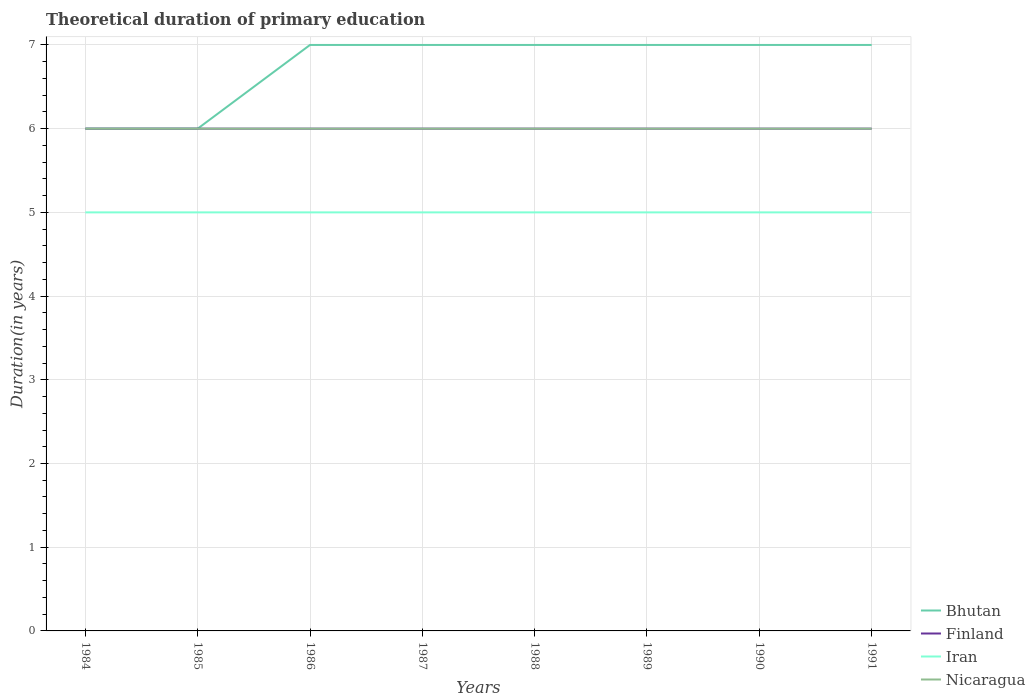Does the line corresponding to Nicaragua intersect with the line corresponding to Finland?
Offer a very short reply. Yes. Is the number of lines equal to the number of legend labels?
Your answer should be compact. Yes. Across all years, what is the maximum total theoretical duration of primary education in Iran?
Your answer should be very brief. 5. How many lines are there?
Your response must be concise. 4. How many years are there in the graph?
Provide a succinct answer. 8. What is the difference between two consecutive major ticks on the Y-axis?
Your response must be concise. 1. Are the values on the major ticks of Y-axis written in scientific E-notation?
Give a very brief answer. No. Does the graph contain any zero values?
Keep it short and to the point. No. Where does the legend appear in the graph?
Your answer should be compact. Bottom right. How many legend labels are there?
Your answer should be very brief. 4. How are the legend labels stacked?
Offer a very short reply. Vertical. What is the title of the graph?
Offer a terse response. Theoretical duration of primary education. Does "Marshall Islands" appear as one of the legend labels in the graph?
Give a very brief answer. No. What is the label or title of the X-axis?
Your response must be concise. Years. What is the label or title of the Y-axis?
Ensure brevity in your answer.  Duration(in years). What is the Duration(in years) in Bhutan in 1984?
Your response must be concise. 6. What is the Duration(in years) of Iran in 1984?
Make the answer very short. 5. What is the Duration(in years) of Nicaragua in 1984?
Offer a terse response. 6. What is the Duration(in years) in Bhutan in 1985?
Provide a short and direct response. 6. What is the Duration(in years) in Iran in 1985?
Provide a succinct answer. 5. What is the Duration(in years) in Nicaragua in 1986?
Offer a terse response. 6. What is the Duration(in years) in Iran in 1987?
Keep it short and to the point. 5. What is the Duration(in years) of Iran in 1988?
Provide a short and direct response. 5. What is the Duration(in years) in Bhutan in 1989?
Ensure brevity in your answer.  7. What is the Duration(in years) in Finland in 1989?
Make the answer very short. 6. What is the Duration(in years) in Nicaragua in 1989?
Make the answer very short. 6. What is the Duration(in years) of Iran in 1990?
Provide a succinct answer. 5. What is the Duration(in years) in Nicaragua in 1990?
Offer a very short reply. 6. What is the Duration(in years) in Bhutan in 1991?
Provide a succinct answer. 7. What is the Duration(in years) of Finland in 1991?
Offer a very short reply. 6. What is the Duration(in years) of Iran in 1991?
Offer a very short reply. 5. What is the Duration(in years) of Nicaragua in 1991?
Make the answer very short. 6. Across all years, what is the maximum Duration(in years) in Nicaragua?
Offer a terse response. 6. Across all years, what is the minimum Duration(in years) of Finland?
Make the answer very short. 6. Across all years, what is the minimum Duration(in years) in Nicaragua?
Your answer should be very brief. 6. What is the total Duration(in years) in Bhutan in the graph?
Keep it short and to the point. 54. What is the difference between the Duration(in years) of Finland in 1984 and that in 1985?
Offer a terse response. 0. What is the difference between the Duration(in years) in Iran in 1984 and that in 1987?
Your answer should be very brief. 0. What is the difference between the Duration(in years) of Nicaragua in 1984 and that in 1988?
Your response must be concise. 0. What is the difference between the Duration(in years) of Bhutan in 1984 and that in 1989?
Provide a short and direct response. -1. What is the difference between the Duration(in years) of Finland in 1984 and that in 1989?
Keep it short and to the point. 0. What is the difference between the Duration(in years) of Iran in 1984 and that in 1989?
Offer a terse response. 0. What is the difference between the Duration(in years) in Bhutan in 1984 and that in 1990?
Your answer should be very brief. -1. What is the difference between the Duration(in years) of Iran in 1984 and that in 1990?
Your answer should be very brief. 0. What is the difference between the Duration(in years) of Nicaragua in 1984 and that in 1990?
Offer a very short reply. 0. What is the difference between the Duration(in years) in Bhutan in 1984 and that in 1991?
Give a very brief answer. -1. What is the difference between the Duration(in years) of Finland in 1984 and that in 1991?
Offer a terse response. 0. What is the difference between the Duration(in years) of Nicaragua in 1984 and that in 1991?
Offer a very short reply. 0. What is the difference between the Duration(in years) in Bhutan in 1985 and that in 1986?
Make the answer very short. -1. What is the difference between the Duration(in years) in Iran in 1985 and that in 1986?
Provide a succinct answer. 0. What is the difference between the Duration(in years) in Nicaragua in 1985 and that in 1986?
Give a very brief answer. 0. What is the difference between the Duration(in years) in Bhutan in 1985 and that in 1987?
Provide a short and direct response. -1. What is the difference between the Duration(in years) in Nicaragua in 1985 and that in 1987?
Your answer should be compact. 0. What is the difference between the Duration(in years) of Bhutan in 1985 and that in 1988?
Ensure brevity in your answer.  -1. What is the difference between the Duration(in years) of Finland in 1985 and that in 1988?
Offer a very short reply. 0. What is the difference between the Duration(in years) in Iran in 1985 and that in 1988?
Provide a succinct answer. 0. What is the difference between the Duration(in years) in Finland in 1985 and that in 1989?
Offer a terse response. 0. What is the difference between the Duration(in years) in Bhutan in 1985 and that in 1990?
Keep it short and to the point. -1. What is the difference between the Duration(in years) of Finland in 1985 and that in 1990?
Provide a succinct answer. 0. What is the difference between the Duration(in years) of Nicaragua in 1985 and that in 1991?
Provide a succinct answer. 0. What is the difference between the Duration(in years) of Bhutan in 1986 and that in 1987?
Your answer should be very brief. 0. What is the difference between the Duration(in years) of Iran in 1986 and that in 1987?
Your response must be concise. 0. What is the difference between the Duration(in years) of Nicaragua in 1986 and that in 1987?
Your response must be concise. 0. What is the difference between the Duration(in years) of Iran in 1986 and that in 1988?
Your response must be concise. 0. What is the difference between the Duration(in years) in Finland in 1986 and that in 1989?
Ensure brevity in your answer.  0. What is the difference between the Duration(in years) of Bhutan in 1986 and that in 1990?
Provide a short and direct response. 0. What is the difference between the Duration(in years) in Finland in 1986 and that in 1990?
Your answer should be very brief. 0. What is the difference between the Duration(in years) in Bhutan in 1986 and that in 1991?
Make the answer very short. 0. What is the difference between the Duration(in years) in Finland in 1987 and that in 1988?
Offer a very short reply. 0. What is the difference between the Duration(in years) of Iran in 1987 and that in 1988?
Offer a terse response. 0. What is the difference between the Duration(in years) in Iran in 1987 and that in 1989?
Give a very brief answer. 0. What is the difference between the Duration(in years) of Finland in 1987 and that in 1990?
Offer a terse response. 0. What is the difference between the Duration(in years) in Iran in 1987 and that in 1990?
Your answer should be very brief. 0. What is the difference between the Duration(in years) in Bhutan in 1987 and that in 1991?
Your answer should be very brief. 0. What is the difference between the Duration(in years) in Finland in 1988 and that in 1989?
Offer a terse response. 0. What is the difference between the Duration(in years) in Iran in 1988 and that in 1989?
Your answer should be very brief. 0. What is the difference between the Duration(in years) in Nicaragua in 1988 and that in 1989?
Your answer should be compact. 0. What is the difference between the Duration(in years) in Nicaragua in 1988 and that in 1990?
Your response must be concise. 0. What is the difference between the Duration(in years) of Iran in 1988 and that in 1991?
Your answer should be very brief. 0. What is the difference between the Duration(in years) in Finland in 1989 and that in 1990?
Offer a terse response. 0. What is the difference between the Duration(in years) of Iran in 1989 and that in 1990?
Your answer should be very brief. 0. What is the difference between the Duration(in years) in Nicaragua in 1989 and that in 1990?
Make the answer very short. 0. What is the difference between the Duration(in years) in Bhutan in 1989 and that in 1991?
Offer a very short reply. 0. What is the difference between the Duration(in years) of Finland in 1989 and that in 1991?
Keep it short and to the point. 0. What is the difference between the Duration(in years) of Iran in 1989 and that in 1991?
Offer a very short reply. 0. What is the difference between the Duration(in years) in Nicaragua in 1989 and that in 1991?
Provide a succinct answer. 0. What is the difference between the Duration(in years) of Finland in 1990 and that in 1991?
Provide a short and direct response. 0. What is the difference between the Duration(in years) of Iran in 1990 and that in 1991?
Give a very brief answer. 0. What is the difference between the Duration(in years) of Bhutan in 1984 and the Duration(in years) of Finland in 1985?
Your answer should be compact. 0. What is the difference between the Duration(in years) in Bhutan in 1984 and the Duration(in years) in Iran in 1985?
Make the answer very short. 1. What is the difference between the Duration(in years) of Bhutan in 1984 and the Duration(in years) of Nicaragua in 1985?
Offer a very short reply. 0. What is the difference between the Duration(in years) of Finland in 1984 and the Duration(in years) of Nicaragua in 1985?
Give a very brief answer. 0. What is the difference between the Duration(in years) of Bhutan in 1984 and the Duration(in years) of Iran in 1986?
Provide a short and direct response. 1. What is the difference between the Duration(in years) of Bhutan in 1984 and the Duration(in years) of Nicaragua in 1986?
Keep it short and to the point. 0. What is the difference between the Duration(in years) in Finland in 1984 and the Duration(in years) in Iran in 1986?
Provide a short and direct response. 1. What is the difference between the Duration(in years) in Bhutan in 1984 and the Duration(in years) in Iran in 1987?
Make the answer very short. 1. What is the difference between the Duration(in years) of Bhutan in 1984 and the Duration(in years) of Nicaragua in 1987?
Ensure brevity in your answer.  0. What is the difference between the Duration(in years) in Finland in 1984 and the Duration(in years) in Nicaragua in 1987?
Make the answer very short. 0. What is the difference between the Duration(in years) of Bhutan in 1984 and the Duration(in years) of Nicaragua in 1988?
Your answer should be very brief. 0. What is the difference between the Duration(in years) in Iran in 1984 and the Duration(in years) in Nicaragua in 1988?
Your answer should be compact. -1. What is the difference between the Duration(in years) in Bhutan in 1984 and the Duration(in years) in Nicaragua in 1989?
Offer a terse response. 0. What is the difference between the Duration(in years) of Finland in 1984 and the Duration(in years) of Nicaragua in 1989?
Provide a succinct answer. 0. What is the difference between the Duration(in years) in Bhutan in 1984 and the Duration(in years) in Iran in 1990?
Offer a very short reply. 1. What is the difference between the Duration(in years) in Bhutan in 1984 and the Duration(in years) in Nicaragua in 1990?
Ensure brevity in your answer.  0. What is the difference between the Duration(in years) of Iran in 1984 and the Duration(in years) of Nicaragua in 1990?
Keep it short and to the point. -1. What is the difference between the Duration(in years) in Finland in 1984 and the Duration(in years) in Iran in 1991?
Provide a succinct answer. 1. What is the difference between the Duration(in years) of Iran in 1984 and the Duration(in years) of Nicaragua in 1991?
Your response must be concise. -1. What is the difference between the Duration(in years) in Bhutan in 1985 and the Duration(in years) in Finland in 1986?
Provide a succinct answer. 0. What is the difference between the Duration(in years) of Bhutan in 1985 and the Duration(in years) of Iran in 1986?
Make the answer very short. 1. What is the difference between the Duration(in years) in Bhutan in 1985 and the Duration(in years) in Nicaragua in 1986?
Give a very brief answer. 0. What is the difference between the Duration(in years) of Bhutan in 1985 and the Duration(in years) of Finland in 1987?
Make the answer very short. 0. What is the difference between the Duration(in years) in Finland in 1985 and the Duration(in years) in Iran in 1987?
Offer a very short reply. 1. What is the difference between the Duration(in years) in Finland in 1985 and the Duration(in years) in Nicaragua in 1987?
Ensure brevity in your answer.  0. What is the difference between the Duration(in years) of Bhutan in 1985 and the Duration(in years) of Iran in 1988?
Make the answer very short. 1. What is the difference between the Duration(in years) in Bhutan in 1985 and the Duration(in years) in Nicaragua in 1988?
Keep it short and to the point. 0. What is the difference between the Duration(in years) of Finland in 1985 and the Duration(in years) of Iran in 1988?
Provide a succinct answer. 1. What is the difference between the Duration(in years) of Finland in 1985 and the Duration(in years) of Nicaragua in 1988?
Your answer should be very brief. 0. What is the difference between the Duration(in years) of Iran in 1985 and the Duration(in years) of Nicaragua in 1988?
Make the answer very short. -1. What is the difference between the Duration(in years) in Bhutan in 1985 and the Duration(in years) in Iran in 1989?
Your answer should be compact. 1. What is the difference between the Duration(in years) of Bhutan in 1985 and the Duration(in years) of Nicaragua in 1989?
Provide a short and direct response. 0. What is the difference between the Duration(in years) in Iran in 1985 and the Duration(in years) in Nicaragua in 1989?
Ensure brevity in your answer.  -1. What is the difference between the Duration(in years) in Bhutan in 1985 and the Duration(in years) in Finland in 1990?
Your response must be concise. 0. What is the difference between the Duration(in years) in Bhutan in 1985 and the Duration(in years) in Iran in 1990?
Your answer should be compact. 1. What is the difference between the Duration(in years) of Bhutan in 1985 and the Duration(in years) of Nicaragua in 1990?
Offer a terse response. 0. What is the difference between the Duration(in years) in Finland in 1985 and the Duration(in years) in Iran in 1990?
Your response must be concise. 1. What is the difference between the Duration(in years) of Iran in 1985 and the Duration(in years) of Nicaragua in 1990?
Provide a succinct answer. -1. What is the difference between the Duration(in years) of Bhutan in 1985 and the Duration(in years) of Iran in 1991?
Ensure brevity in your answer.  1. What is the difference between the Duration(in years) in Bhutan in 1985 and the Duration(in years) in Nicaragua in 1991?
Ensure brevity in your answer.  0. What is the difference between the Duration(in years) of Iran in 1985 and the Duration(in years) of Nicaragua in 1991?
Provide a short and direct response. -1. What is the difference between the Duration(in years) of Bhutan in 1986 and the Duration(in years) of Finland in 1987?
Offer a very short reply. 1. What is the difference between the Duration(in years) of Finland in 1986 and the Duration(in years) of Iran in 1987?
Ensure brevity in your answer.  1. What is the difference between the Duration(in years) in Finland in 1986 and the Duration(in years) in Nicaragua in 1987?
Give a very brief answer. 0. What is the difference between the Duration(in years) in Bhutan in 1986 and the Duration(in years) in Finland in 1988?
Make the answer very short. 1. What is the difference between the Duration(in years) in Bhutan in 1986 and the Duration(in years) in Nicaragua in 1988?
Your answer should be compact. 1. What is the difference between the Duration(in years) of Finland in 1986 and the Duration(in years) of Iran in 1988?
Provide a succinct answer. 1. What is the difference between the Duration(in years) in Finland in 1986 and the Duration(in years) in Nicaragua in 1988?
Offer a very short reply. 0. What is the difference between the Duration(in years) in Bhutan in 1986 and the Duration(in years) in Finland in 1989?
Give a very brief answer. 1. What is the difference between the Duration(in years) of Bhutan in 1986 and the Duration(in years) of Iran in 1989?
Ensure brevity in your answer.  2. What is the difference between the Duration(in years) in Bhutan in 1986 and the Duration(in years) in Nicaragua in 1989?
Your answer should be compact. 1. What is the difference between the Duration(in years) of Finland in 1986 and the Duration(in years) of Iran in 1989?
Give a very brief answer. 1. What is the difference between the Duration(in years) of Iran in 1986 and the Duration(in years) of Nicaragua in 1989?
Provide a succinct answer. -1. What is the difference between the Duration(in years) of Bhutan in 1986 and the Duration(in years) of Finland in 1990?
Provide a short and direct response. 1. What is the difference between the Duration(in years) of Bhutan in 1986 and the Duration(in years) of Iran in 1990?
Offer a terse response. 2. What is the difference between the Duration(in years) of Bhutan in 1986 and the Duration(in years) of Nicaragua in 1990?
Your answer should be compact. 1. What is the difference between the Duration(in years) of Finland in 1986 and the Duration(in years) of Nicaragua in 1990?
Make the answer very short. 0. What is the difference between the Duration(in years) in Iran in 1986 and the Duration(in years) in Nicaragua in 1990?
Make the answer very short. -1. What is the difference between the Duration(in years) of Bhutan in 1986 and the Duration(in years) of Finland in 1991?
Offer a terse response. 1. What is the difference between the Duration(in years) in Bhutan in 1986 and the Duration(in years) in Nicaragua in 1991?
Ensure brevity in your answer.  1. What is the difference between the Duration(in years) in Finland in 1986 and the Duration(in years) in Iran in 1991?
Keep it short and to the point. 1. What is the difference between the Duration(in years) in Iran in 1986 and the Duration(in years) in Nicaragua in 1991?
Provide a short and direct response. -1. What is the difference between the Duration(in years) of Bhutan in 1987 and the Duration(in years) of Finland in 1988?
Provide a succinct answer. 1. What is the difference between the Duration(in years) in Bhutan in 1987 and the Duration(in years) in Nicaragua in 1988?
Your response must be concise. 1. What is the difference between the Duration(in years) in Finland in 1987 and the Duration(in years) in Iran in 1988?
Offer a terse response. 1. What is the difference between the Duration(in years) in Bhutan in 1987 and the Duration(in years) in Finland in 1989?
Keep it short and to the point. 1. What is the difference between the Duration(in years) of Bhutan in 1987 and the Duration(in years) of Nicaragua in 1989?
Provide a short and direct response. 1. What is the difference between the Duration(in years) in Finland in 1987 and the Duration(in years) in Nicaragua in 1989?
Your answer should be very brief. 0. What is the difference between the Duration(in years) in Bhutan in 1987 and the Duration(in years) in Finland in 1990?
Offer a terse response. 1. What is the difference between the Duration(in years) in Bhutan in 1987 and the Duration(in years) in Iran in 1990?
Your response must be concise. 2. What is the difference between the Duration(in years) of Iran in 1987 and the Duration(in years) of Nicaragua in 1990?
Your response must be concise. -1. What is the difference between the Duration(in years) of Bhutan in 1987 and the Duration(in years) of Iran in 1991?
Ensure brevity in your answer.  2. What is the difference between the Duration(in years) of Finland in 1987 and the Duration(in years) of Iran in 1991?
Make the answer very short. 1. What is the difference between the Duration(in years) of Iran in 1987 and the Duration(in years) of Nicaragua in 1991?
Keep it short and to the point. -1. What is the difference between the Duration(in years) in Bhutan in 1988 and the Duration(in years) in Iran in 1989?
Provide a succinct answer. 2. What is the difference between the Duration(in years) of Finland in 1988 and the Duration(in years) of Iran in 1989?
Keep it short and to the point. 1. What is the difference between the Duration(in years) in Bhutan in 1988 and the Duration(in years) in Iran in 1990?
Provide a short and direct response. 2. What is the difference between the Duration(in years) in Finland in 1988 and the Duration(in years) in Iran in 1990?
Ensure brevity in your answer.  1. What is the difference between the Duration(in years) in Bhutan in 1988 and the Duration(in years) in Finland in 1991?
Offer a terse response. 1. What is the difference between the Duration(in years) of Iran in 1988 and the Duration(in years) of Nicaragua in 1991?
Provide a succinct answer. -1. What is the difference between the Duration(in years) in Bhutan in 1989 and the Duration(in years) in Finland in 1990?
Ensure brevity in your answer.  1. What is the difference between the Duration(in years) in Bhutan in 1989 and the Duration(in years) in Iran in 1990?
Keep it short and to the point. 2. What is the difference between the Duration(in years) of Bhutan in 1989 and the Duration(in years) of Nicaragua in 1990?
Give a very brief answer. 1. What is the difference between the Duration(in years) of Finland in 1989 and the Duration(in years) of Iran in 1990?
Ensure brevity in your answer.  1. What is the difference between the Duration(in years) of Iran in 1989 and the Duration(in years) of Nicaragua in 1990?
Give a very brief answer. -1. What is the difference between the Duration(in years) of Bhutan in 1989 and the Duration(in years) of Iran in 1991?
Offer a terse response. 2. What is the difference between the Duration(in years) in Bhutan in 1989 and the Duration(in years) in Nicaragua in 1991?
Offer a terse response. 1. What is the difference between the Duration(in years) of Finland in 1989 and the Duration(in years) of Iran in 1991?
Ensure brevity in your answer.  1. What is the difference between the Duration(in years) of Finland in 1989 and the Duration(in years) of Nicaragua in 1991?
Offer a very short reply. 0. What is the difference between the Duration(in years) in Bhutan in 1990 and the Duration(in years) in Finland in 1991?
Keep it short and to the point. 1. What is the average Duration(in years) in Bhutan per year?
Provide a short and direct response. 6.75. What is the average Duration(in years) in Iran per year?
Your answer should be compact. 5. What is the average Duration(in years) of Nicaragua per year?
Make the answer very short. 6. In the year 1984, what is the difference between the Duration(in years) of Bhutan and Duration(in years) of Finland?
Give a very brief answer. 0. In the year 1984, what is the difference between the Duration(in years) of Finland and Duration(in years) of Iran?
Your answer should be very brief. 1. In the year 1985, what is the difference between the Duration(in years) in Bhutan and Duration(in years) in Finland?
Keep it short and to the point. 0. In the year 1985, what is the difference between the Duration(in years) of Bhutan and Duration(in years) of Iran?
Make the answer very short. 1. In the year 1986, what is the difference between the Duration(in years) in Bhutan and Duration(in years) in Finland?
Give a very brief answer. 1. In the year 1986, what is the difference between the Duration(in years) in Bhutan and Duration(in years) in Iran?
Provide a short and direct response. 2. In the year 1987, what is the difference between the Duration(in years) of Bhutan and Duration(in years) of Finland?
Ensure brevity in your answer.  1. In the year 1987, what is the difference between the Duration(in years) in Finland and Duration(in years) in Iran?
Ensure brevity in your answer.  1. In the year 1987, what is the difference between the Duration(in years) in Iran and Duration(in years) in Nicaragua?
Keep it short and to the point. -1. In the year 1988, what is the difference between the Duration(in years) of Finland and Duration(in years) of Iran?
Provide a short and direct response. 1. In the year 1988, what is the difference between the Duration(in years) in Finland and Duration(in years) in Nicaragua?
Offer a very short reply. 0. In the year 1989, what is the difference between the Duration(in years) of Bhutan and Duration(in years) of Finland?
Provide a succinct answer. 1. In the year 1989, what is the difference between the Duration(in years) of Bhutan and Duration(in years) of Iran?
Provide a short and direct response. 2. In the year 1989, what is the difference between the Duration(in years) in Bhutan and Duration(in years) in Nicaragua?
Your answer should be compact. 1. In the year 1989, what is the difference between the Duration(in years) of Finland and Duration(in years) of Iran?
Keep it short and to the point. 1. In the year 1989, what is the difference between the Duration(in years) of Iran and Duration(in years) of Nicaragua?
Make the answer very short. -1. In the year 1990, what is the difference between the Duration(in years) in Bhutan and Duration(in years) in Nicaragua?
Give a very brief answer. 1. In the year 1990, what is the difference between the Duration(in years) of Finland and Duration(in years) of Iran?
Give a very brief answer. 1. In the year 1990, what is the difference between the Duration(in years) of Iran and Duration(in years) of Nicaragua?
Give a very brief answer. -1. What is the ratio of the Duration(in years) of Finland in 1984 to that in 1985?
Your response must be concise. 1. What is the ratio of the Duration(in years) of Iran in 1984 to that in 1985?
Offer a terse response. 1. What is the ratio of the Duration(in years) in Nicaragua in 1984 to that in 1985?
Provide a short and direct response. 1. What is the ratio of the Duration(in years) in Bhutan in 1984 to that in 1986?
Your response must be concise. 0.86. What is the ratio of the Duration(in years) in Iran in 1984 to that in 1986?
Keep it short and to the point. 1. What is the ratio of the Duration(in years) in Nicaragua in 1984 to that in 1986?
Provide a short and direct response. 1. What is the ratio of the Duration(in years) in Bhutan in 1984 to that in 1987?
Make the answer very short. 0.86. What is the ratio of the Duration(in years) in Nicaragua in 1984 to that in 1988?
Offer a terse response. 1. What is the ratio of the Duration(in years) of Finland in 1984 to that in 1989?
Offer a terse response. 1. What is the ratio of the Duration(in years) in Iran in 1984 to that in 1989?
Keep it short and to the point. 1. What is the ratio of the Duration(in years) of Bhutan in 1984 to that in 1990?
Provide a short and direct response. 0.86. What is the ratio of the Duration(in years) in Finland in 1984 to that in 1990?
Your answer should be compact. 1. What is the ratio of the Duration(in years) of Nicaragua in 1984 to that in 1990?
Keep it short and to the point. 1. What is the ratio of the Duration(in years) in Bhutan in 1984 to that in 1991?
Provide a succinct answer. 0.86. What is the ratio of the Duration(in years) of Nicaragua in 1984 to that in 1991?
Offer a terse response. 1. What is the ratio of the Duration(in years) in Finland in 1985 to that in 1986?
Offer a terse response. 1. What is the ratio of the Duration(in years) in Bhutan in 1985 to that in 1987?
Ensure brevity in your answer.  0.86. What is the ratio of the Duration(in years) in Bhutan in 1985 to that in 1988?
Provide a short and direct response. 0.86. What is the ratio of the Duration(in years) of Iran in 1985 to that in 1988?
Keep it short and to the point. 1. What is the ratio of the Duration(in years) in Nicaragua in 1985 to that in 1988?
Your answer should be compact. 1. What is the ratio of the Duration(in years) in Nicaragua in 1985 to that in 1989?
Provide a short and direct response. 1. What is the ratio of the Duration(in years) of Bhutan in 1985 to that in 1990?
Your answer should be very brief. 0.86. What is the ratio of the Duration(in years) in Finland in 1985 to that in 1990?
Your response must be concise. 1. What is the ratio of the Duration(in years) in Nicaragua in 1985 to that in 1990?
Ensure brevity in your answer.  1. What is the ratio of the Duration(in years) in Bhutan in 1985 to that in 1991?
Provide a short and direct response. 0.86. What is the ratio of the Duration(in years) of Iran in 1985 to that in 1991?
Provide a succinct answer. 1. What is the ratio of the Duration(in years) in Bhutan in 1986 to that in 1987?
Give a very brief answer. 1. What is the ratio of the Duration(in years) of Finland in 1986 to that in 1987?
Your answer should be compact. 1. What is the ratio of the Duration(in years) in Bhutan in 1986 to that in 1988?
Keep it short and to the point. 1. What is the ratio of the Duration(in years) of Iran in 1986 to that in 1988?
Your answer should be compact. 1. What is the ratio of the Duration(in years) in Finland in 1986 to that in 1989?
Your response must be concise. 1. What is the ratio of the Duration(in years) in Nicaragua in 1986 to that in 1989?
Provide a short and direct response. 1. What is the ratio of the Duration(in years) of Finland in 1986 to that in 1990?
Ensure brevity in your answer.  1. What is the ratio of the Duration(in years) in Bhutan in 1986 to that in 1991?
Your answer should be very brief. 1. What is the ratio of the Duration(in years) of Finland in 1986 to that in 1991?
Ensure brevity in your answer.  1. What is the ratio of the Duration(in years) in Finland in 1987 to that in 1988?
Your answer should be very brief. 1. What is the ratio of the Duration(in years) in Bhutan in 1987 to that in 1989?
Your response must be concise. 1. What is the ratio of the Duration(in years) in Iran in 1987 to that in 1989?
Provide a succinct answer. 1. What is the ratio of the Duration(in years) of Finland in 1987 to that in 1990?
Provide a short and direct response. 1. What is the ratio of the Duration(in years) of Iran in 1987 to that in 1990?
Offer a very short reply. 1. What is the ratio of the Duration(in years) of Nicaragua in 1987 to that in 1990?
Give a very brief answer. 1. What is the ratio of the Duration(in years) of Bhutan in 1987 to that in 1991?
Ensure brevity in your answer.  1. What is the ratio of the Duration(in years) of Finland in 1988 to that in 1989?
Offer a terse response. 1. What is the ratio of the Duration(in years) in Iran in 1988 to that in 1989?
Keep it short and to the point. 1. What is the ratio of the Duration(in years) in Nicaragua in 1988 to that in 1989?
Your response must be concise. 1. What is the ratio of the Duration(in years) in Finland in 1988 to that in 1990?
Provide a succinct answer. 1. What is the ratio of the Duration(in years) of Iran in 1988 to that in 1990?
Give a very brief answer. 1. What is the ratio of the Duration(in years) in Bhutan in 1988 to that in 1991?
Offer a terse response. 1. What is the ratio of the Duration(in years) in Finland in 1988 to that in 1991?
Give a very brief answer. 1. What is the ratio of the Duration(in years) in Iran in 1988 to that in 1991?
Offer a very short reply. 1. What is the ratio of the Duration(in years) in Nicaragua in 1988 to that in 1991?
Provide a succinct answer. 1. What is the ratio of the Duration(in years) of Bhutan in 1989 to that in 1990?
Give a very brief answer. 1. What is the ratio of the Duration(in years) in Finland in 1989 to that in 1990?
Offer a very short reply. 1. What is the ratio of the Duration(in years) in Bhutan in 1989 to that in 1991?
Ensure brevity in your answer.  1. What is the ratio of the Duration(in years) of Nicaragua in 1989 to that in 1991?
Your answer should be compact. 1. What is the ratio of the Duration(in years) of Iran in 1990 to that in 1991?
Provide a succinct answer. 1. What is the difference between the highest and the second highest Duration(in years) of Iran?
Provide a short and direct response. 0. What is the difference between the highest and the lowest Duration(in years) of Bhutan?
Offer a terse response. 1. What is the difference between the highest and the lowest Duration(in years) in Finland?
Provide a short and direct response. 0. What is the difference between the highest and the lowest Duration(in years) of Iran?
Offer a very short reply. 0. What is the difference between the highest and the lowest Duration(in years) of Nicaragua?
Provide a succinct answer. 0. 